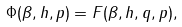<formula> <loc_0><loc_0><loc_500><loc_500>\Phi ( \beta , h , p ) = F ( \beta , h , q , p ) ,</formula> 